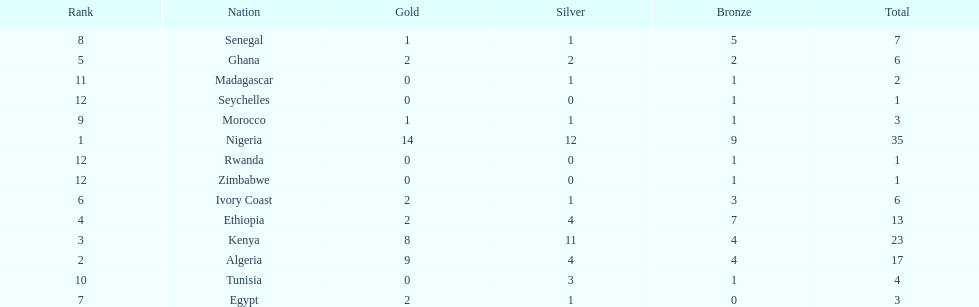How many medals did senegal win? 7. 